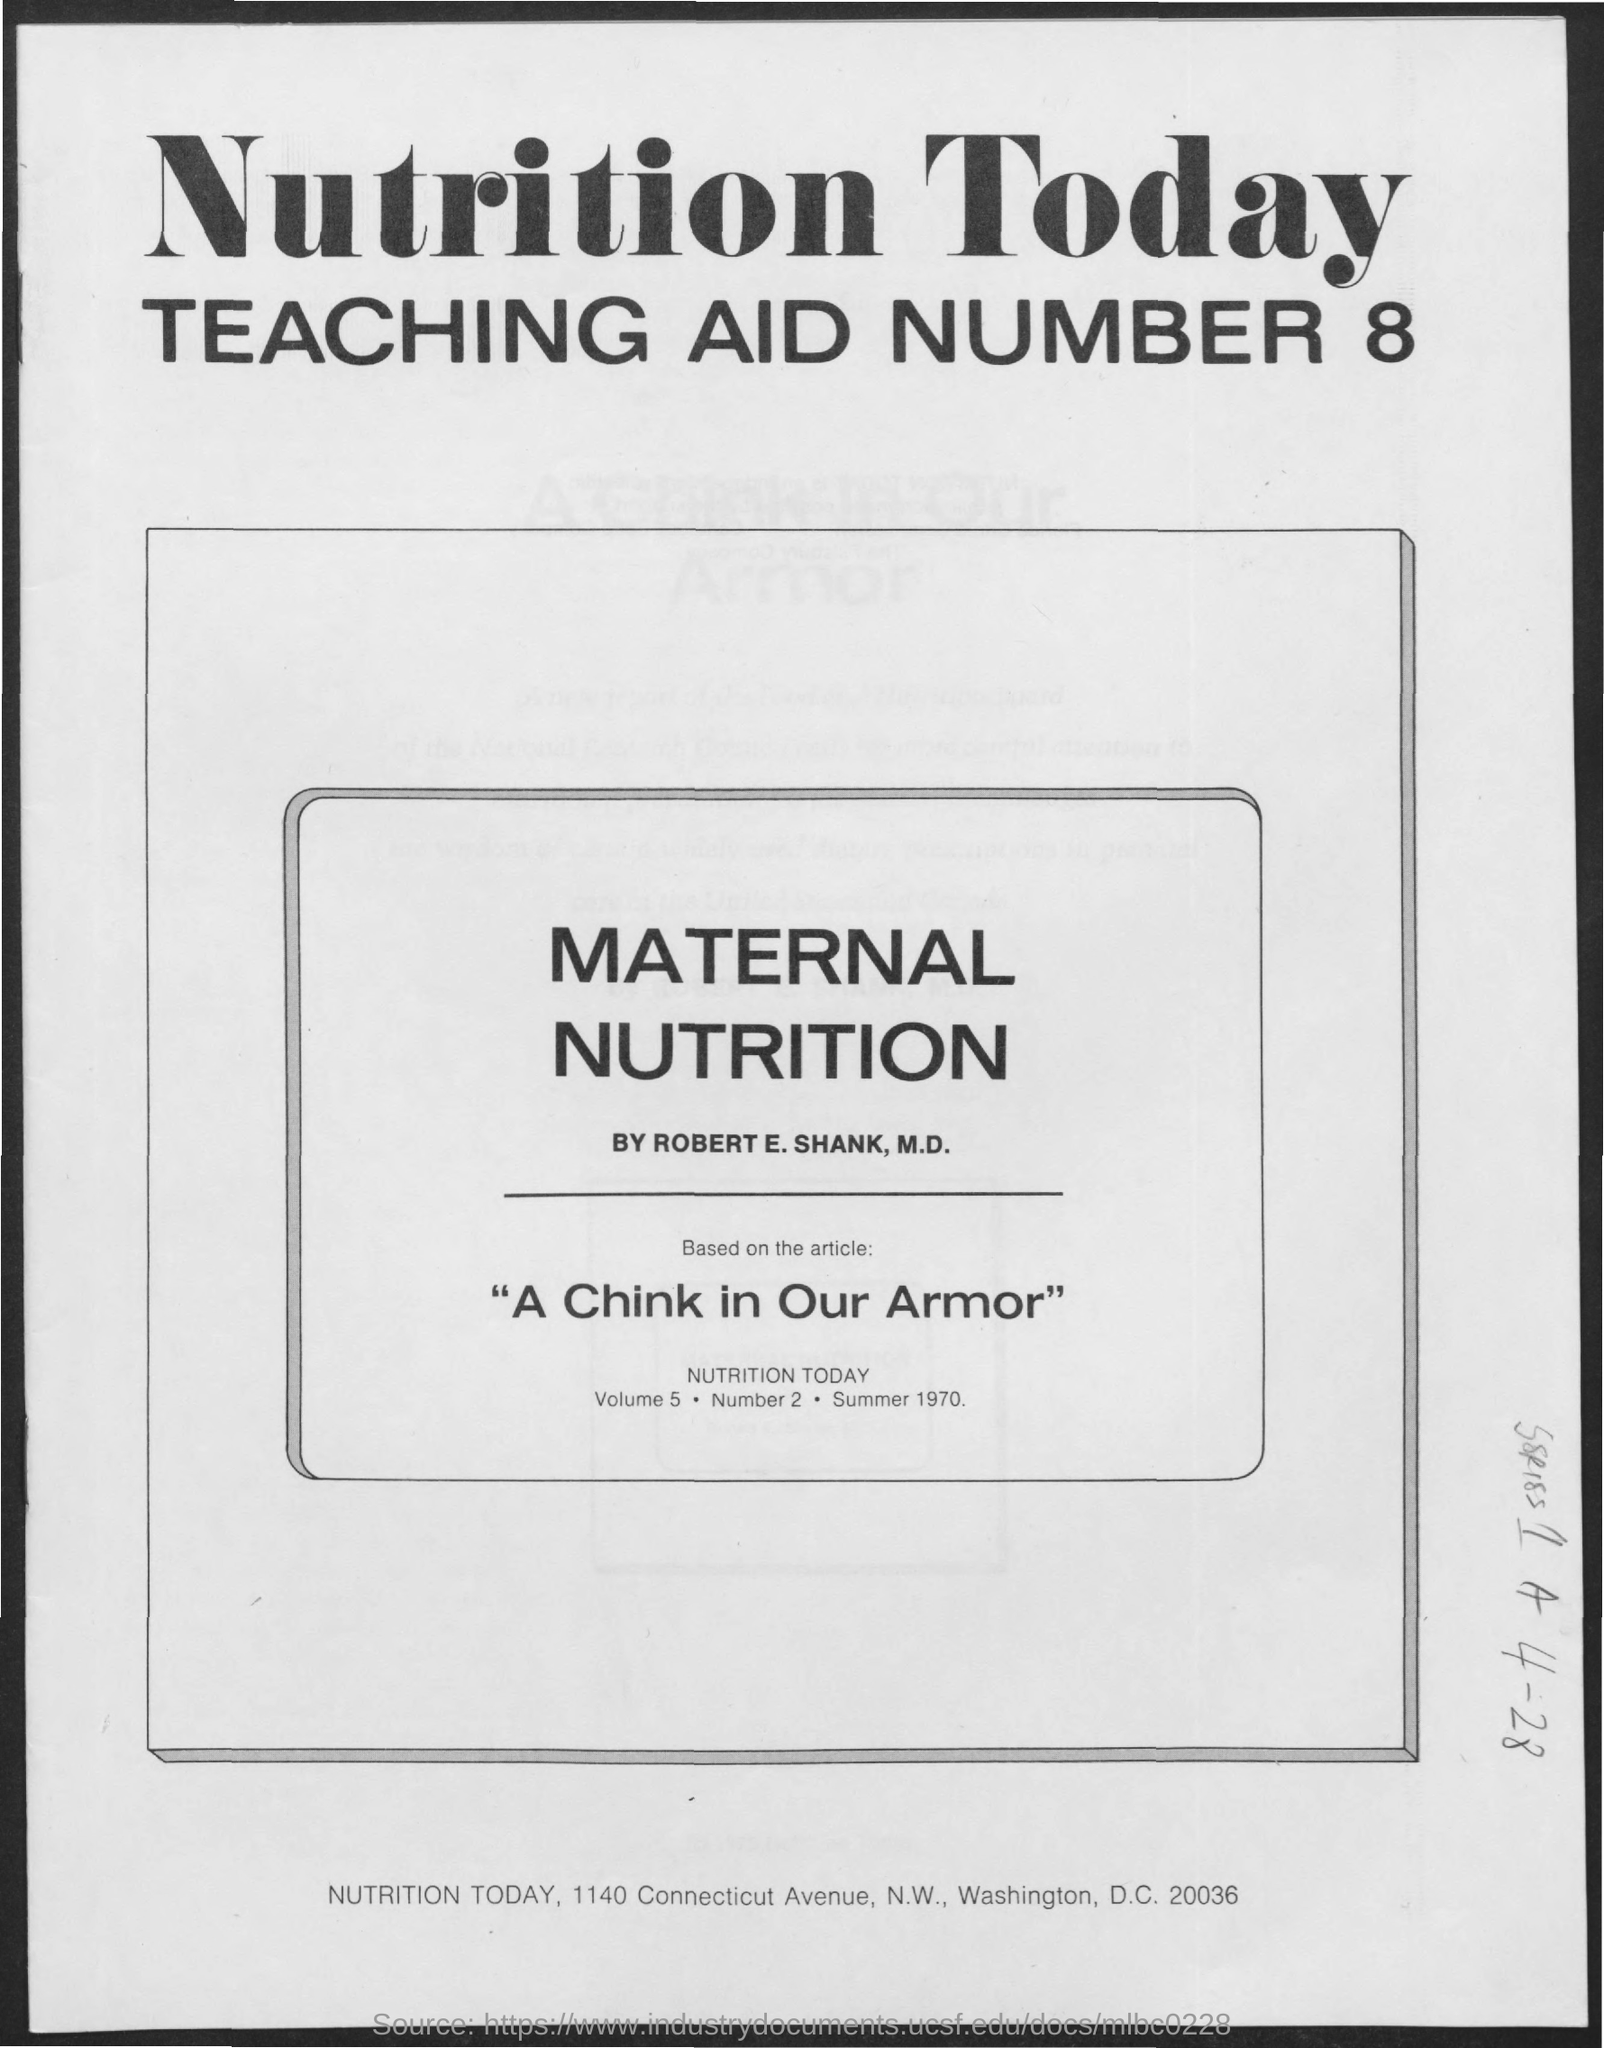The article is written by whom?
Make the answer very short. ROBERT E. SHANK. Which article is it based on?
Your answer should be very brief. "A chink in our armor". What is the Volume?
Ensure brevity in your answer.  5. 